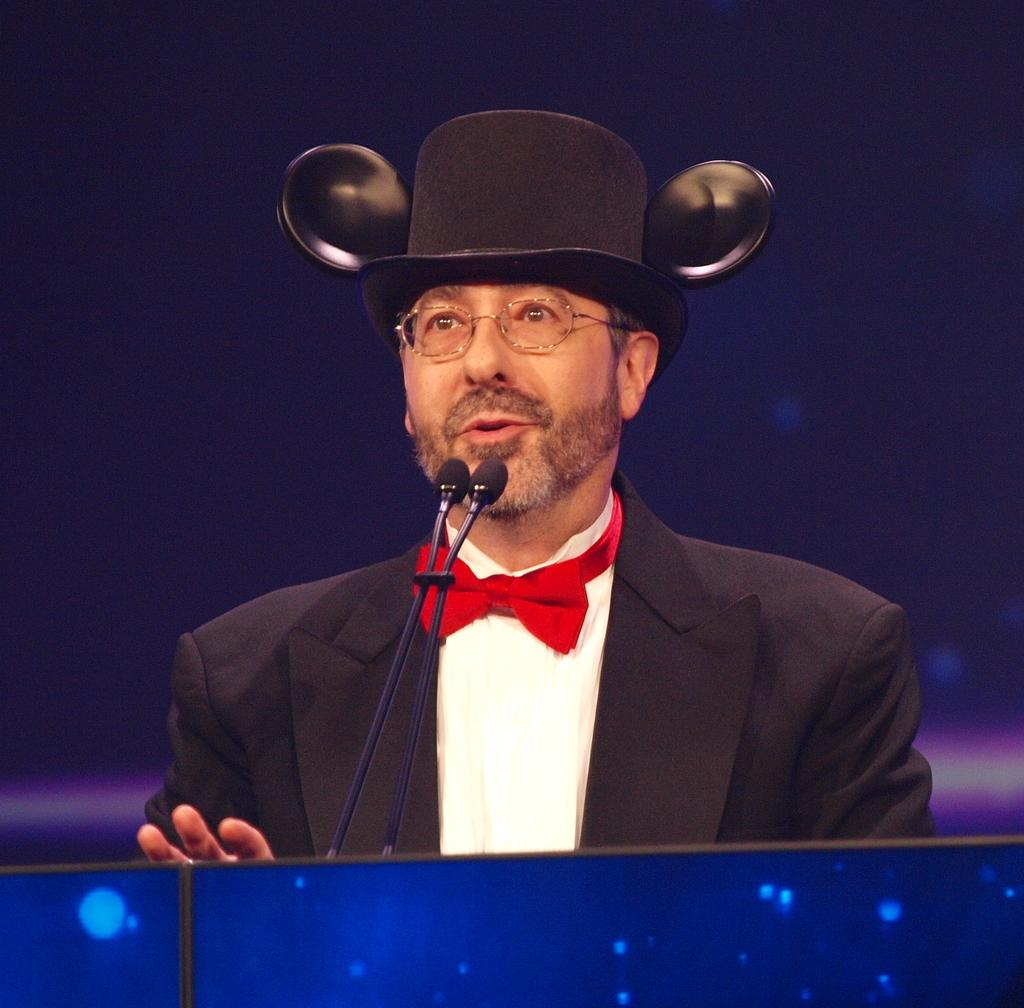What is the man in the image doing near the podium? The man is standing near a podium in the image. What objects are present that might be used for amplifying sound? There are microphones (mike's) in the image. What can be seen in the background of the image? There is a wall in the background of the image. What type of chin is visible on the language in the image? There is no chin or language present in the image; it features a man standing near a podium with microphones. 